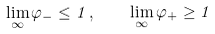Convert formula to latex. <formula><loc_0><loc_0><loc_500><loc_500>\lim _ { \infty } \varphi _ { - } \leq 1 \, , \quad \lim _ { \infty } \varphi _ { + } \geq 1</formula> 